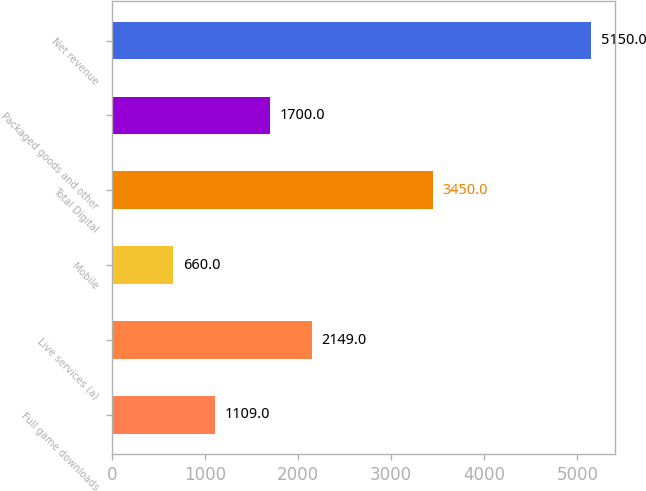Convert chart. <chart><loc_0><loc_0><loc_500><loc_500><bar_chart><fcel>Full game downloads<fcel>Live services (a)<fcel>Mobile<fcel>Total Digital<fcel>Packaged goods and other<fcel>Net revenue<nl><fcel>1109<fcel>2149<fcel>660<fcel>3450<fcel>1700<fcel>5150<nl></chart> 